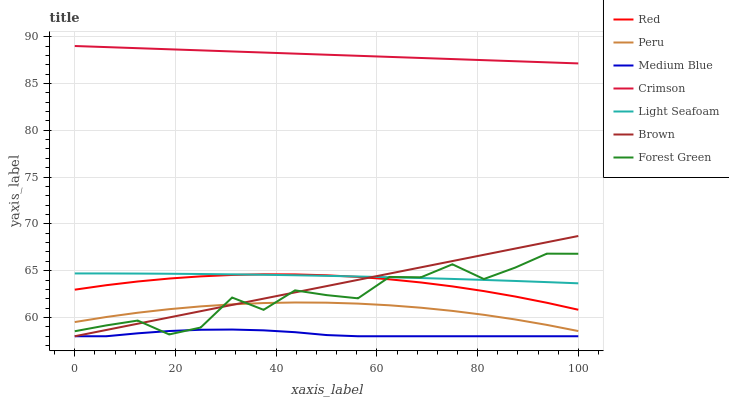Does Medium Blue have the minimum area under the curve?
Answer yes or no. Yes. Does Crimson have the maximum area under the curve?
Answer yes or no. Yes. Does Forest Green have the minimum area under the curve?
Answer yes or no. No. Does Forest Green have the maximum area under the curve?
Answer yes or no. No. Is Crimson the smoothest?
Answer yes or no. Yes. Is Forest Green the roughest?
Answer yes or no. Yes. Is Medium Blue the smoothest?
Answer yes or no. No. Is Medium Blue the roughest?
Answer yes or no. No. Does Forest Green have the lowest value?
Answer yes or no. No. Does Crimson have the highest value?
Answer yes or no. Yes. Does Forest Green have the highest value?
Answer yes or no. No. Is Medium Blue less than Peru?
Answer yes or no. Yes. Is Crimson greater than Brown?
Answer yes or no. Yes. Does Medium Blue intersect Peru?
Answer yes or no. No. 